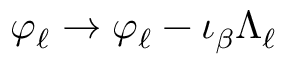Convert formula to latex. <formula><loc_0><loc_0><loc_500><loc_500>\varphi _ { \ell } \to \varphi _ { \ell } - \iota _ { \beta } \Lambda _ { \ell }</formula> 